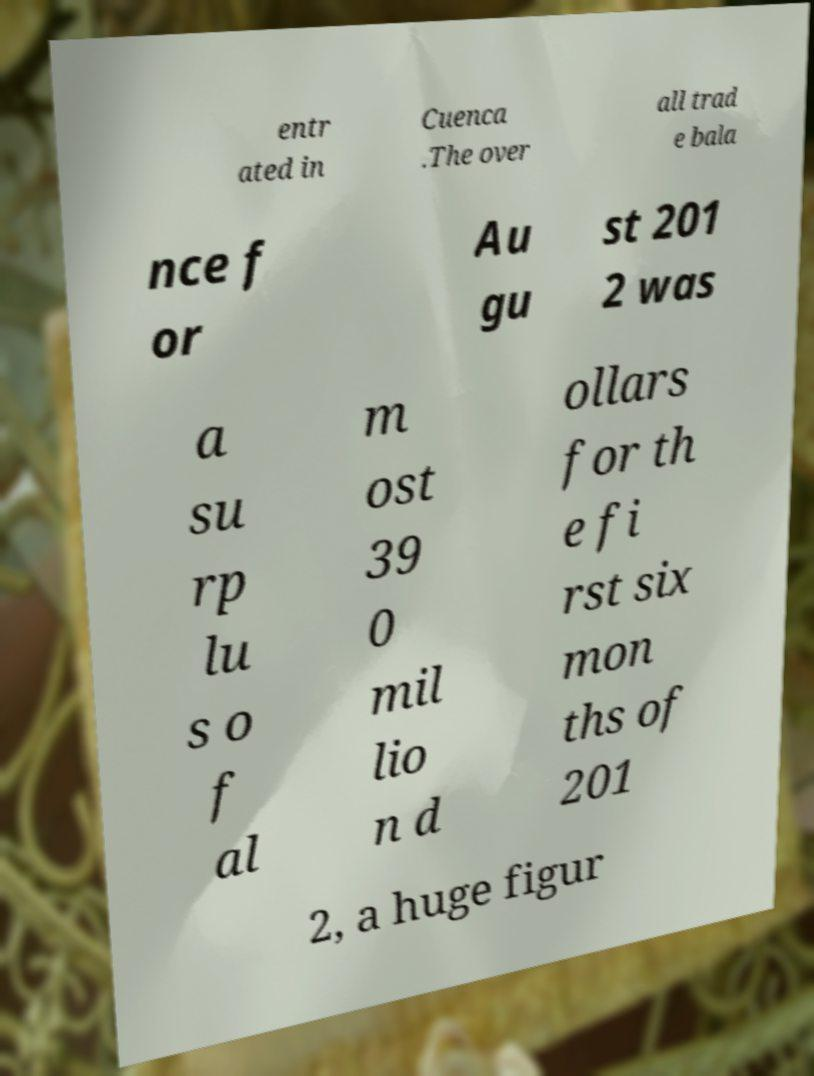For documentation purposes, I need the text within this image transcribed. Could you provide that? entr ated in Cuenca .The over all trad e bala nce f or Au gu st 201 2 was a su rp lu s o f al m ost 39 0 mil lio n d ollars for th e fi rst six mon ths of 201 2, a huge figur 